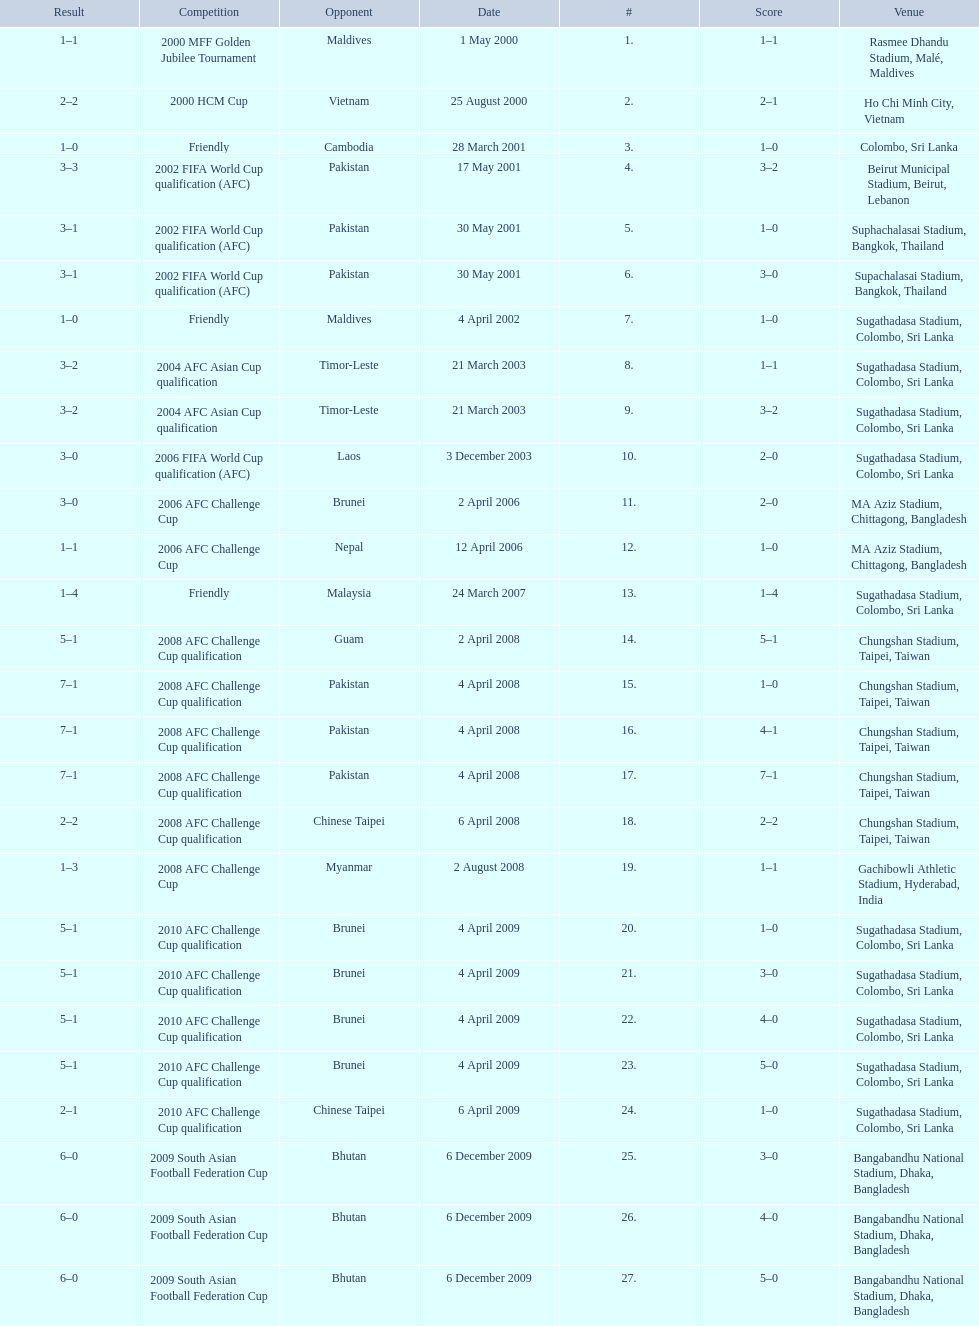Which venue has the largest result Chungshan Stadium, Taipei, Taiwan. 